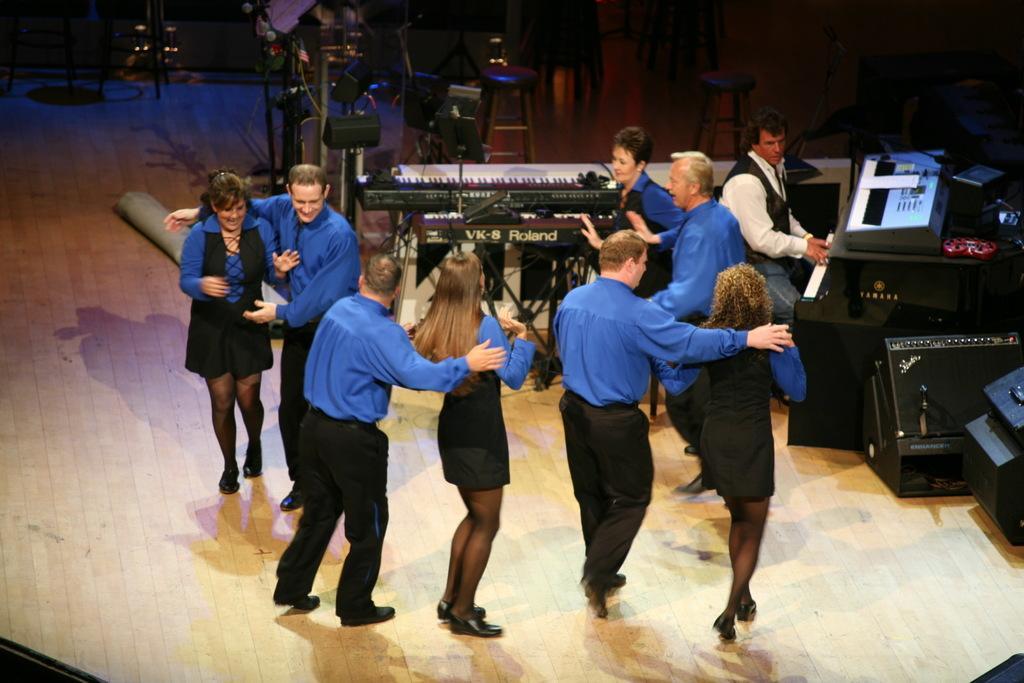Can you describe this image briefly? In this picture I can see there are a group of people standing on the dais and they are wearing blue shirts and black pants and the women are wearing blue and black dresses and there is a person in the backdrop playing a piano. 